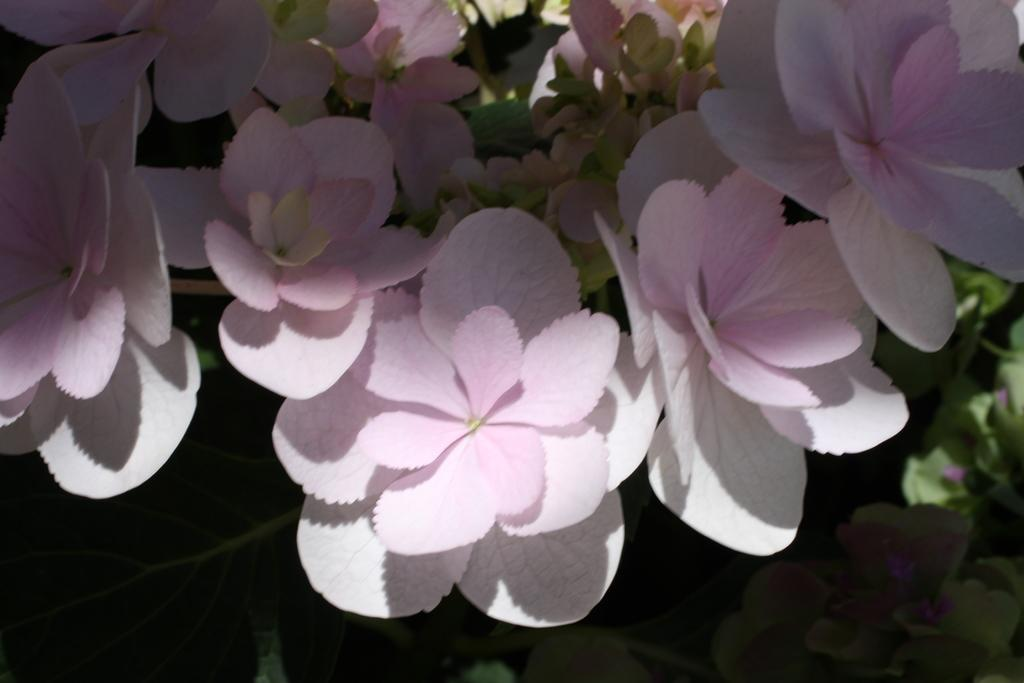What colors of flowers can be seen in the image? There are white and pink flowers in the image. What color are the leaves in the background of the image? The leaves in the background of the image are green. What type of veil is draped over the committee's face in the image? There is no veil or committee present in the image; it features white and pink flowers with green leaves in the background. 